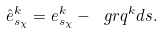<formula> <loc_0><loc_0><loc_500><loc_500>\hat { e } ^ { k } _ { s _ { \chi } } = e ^ { k } _ { s _ { \chi } } - \ g r q ^ { k } d s .</formula> 